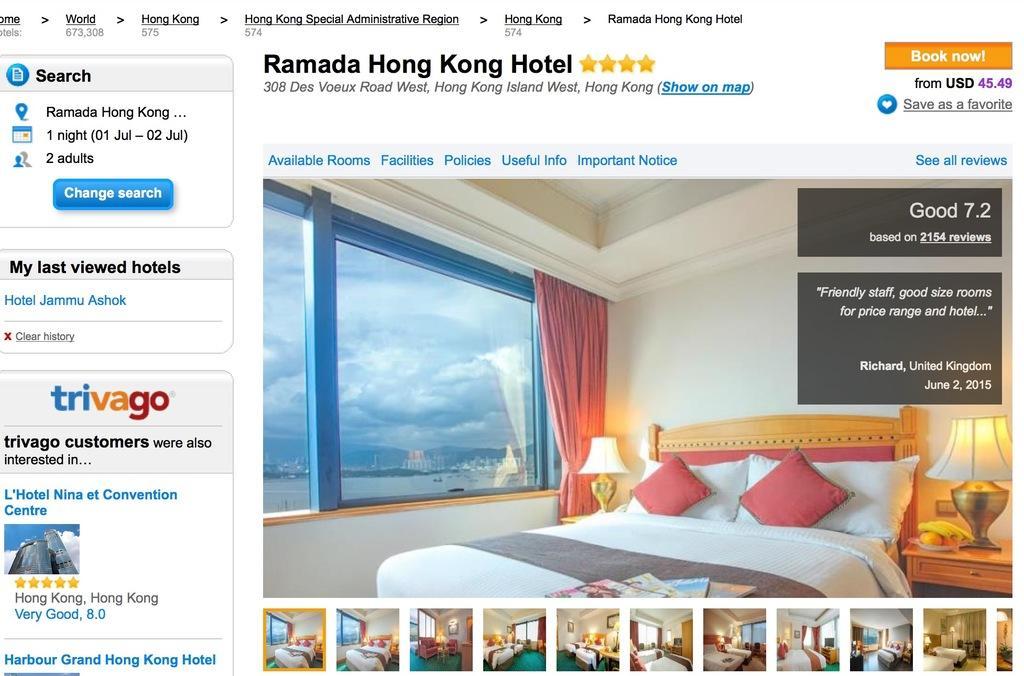How would you summarize this image in a sentence or two? In this Image I see a website in which there is lot of information and I see the pics of a room, in which there is bed, lamps, curtain and a windows. 